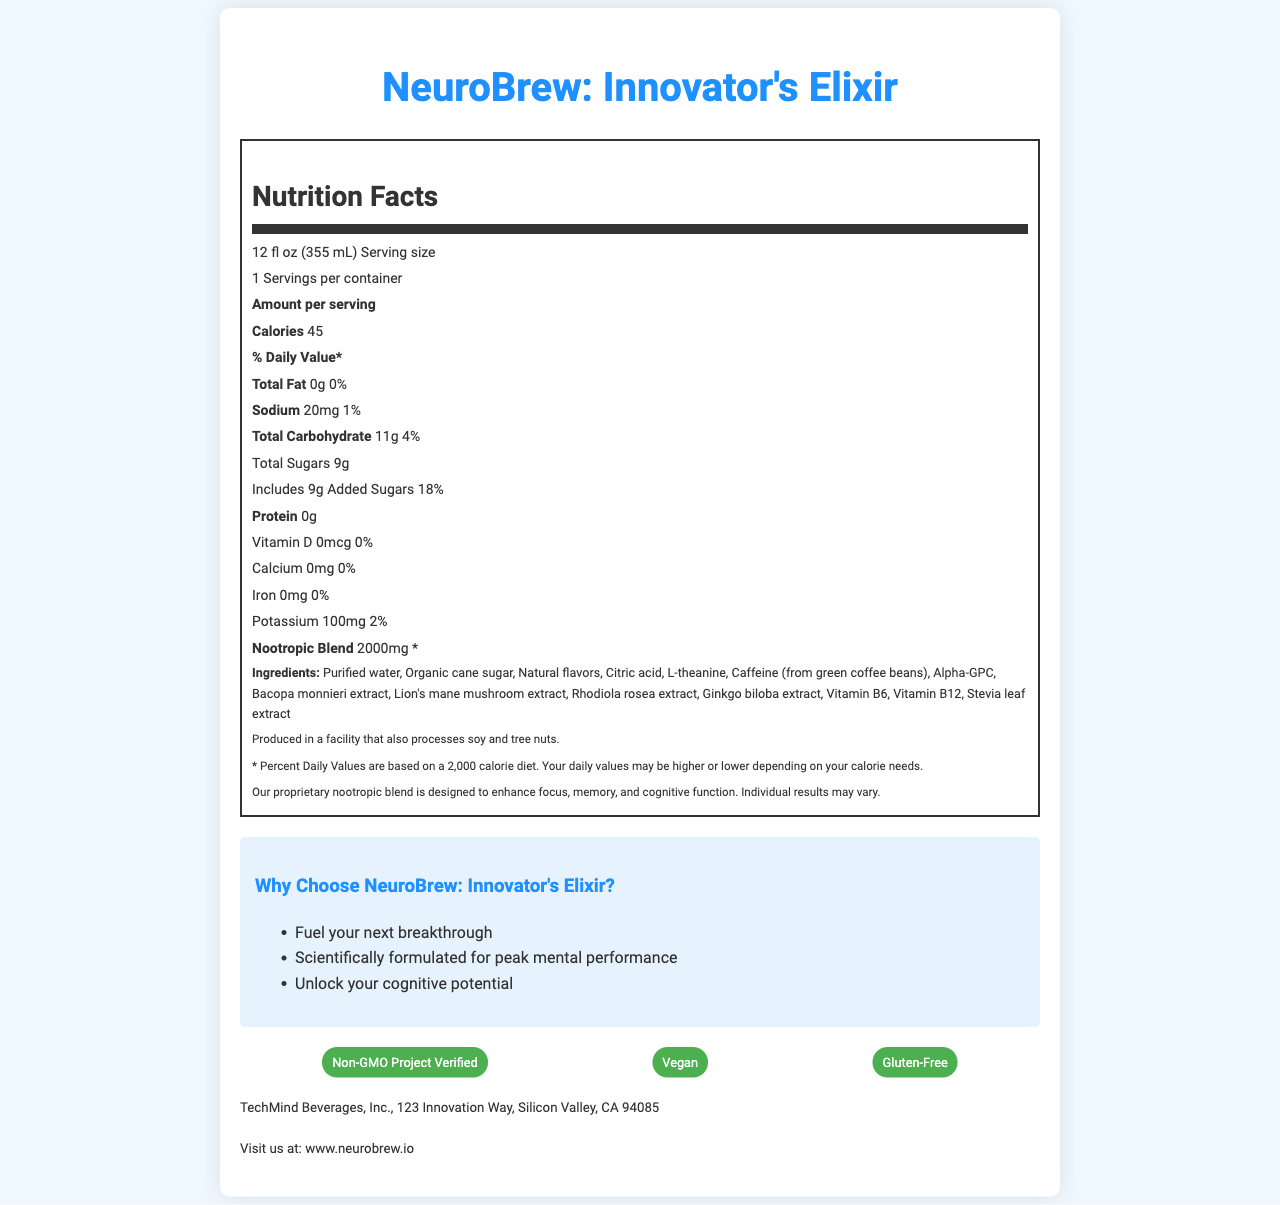what is the total fat per serving? The nutrition label shows that the total fat per serving is 0g.
Answer: 0g how much sodium is in one serving? The nutrition label lists sodium content as 20mg per serving.
Answer: 20mg what is the amount of potassium in the beverage? The nutrition label indicates that there are 100mg of potassium per serving.
Answer: 100mg how many servings are in each container? The label states that there is 1 serving per container.
Answer: 1 what is the daily value percentage of total carbohydrates? The nutrition label lists the daily value for total carbohydrates as 4%.
Answer: 4% which company produces NeuroBrew? A. HealthPlus Corp B. TechMind Beverages, Inc. C. Brain Fuel Inc. The company information section specifies that TechMind Beverages, Inc. produces the beverage.
Answer: B how many grams of protein are in a serving? A. 0g B. 1g C. 2g D. 3g The nutrition label states that there are 0g of protein per serving.
Answer: A is the beverage gluten-free? One of the certifications listed is "Gluten-Free," indicating that the beverage is gluten-free.
Answer: Yes does the nootropic blend have a specified daily value percentage? The nutrition label mentions that the nootropic blend has an unspecified daily value (*).
Answer: No briefly describe the main focus of the document The document includes the serving size, calories, and various nutrient amounts including total fat, sodium, total carbohydrates, sugars, protein, vitamins, and minerals. Additionally, it lists the nootropic blend content and marketing claims about enhancing cognitive function.
Answer: The document is a detailed nutrition facts label for NeuroBrew: Innovator's Elixir, a brain-enhancing nootropic beverage. It includes nutritional information, ingredients, allergen info, marketing claims, and company details. how much Vitamin B12 is in the beverage? The label does not provide specific information regarding the amount of Vitamin B12.
Answer: Not enough information what flavors are present in the drink? The ingredients list includes "Natural flavors," but does not specify individual flavors.
Answer: Natural flavors what is the purpose of NeuroBrew's nootropic blend? The document includes a nootropic info section stating that the proprietary blend is designed to enhance focus, memory, and cognitive function.
Answer: To enhance focus, memory, and cognitive function 